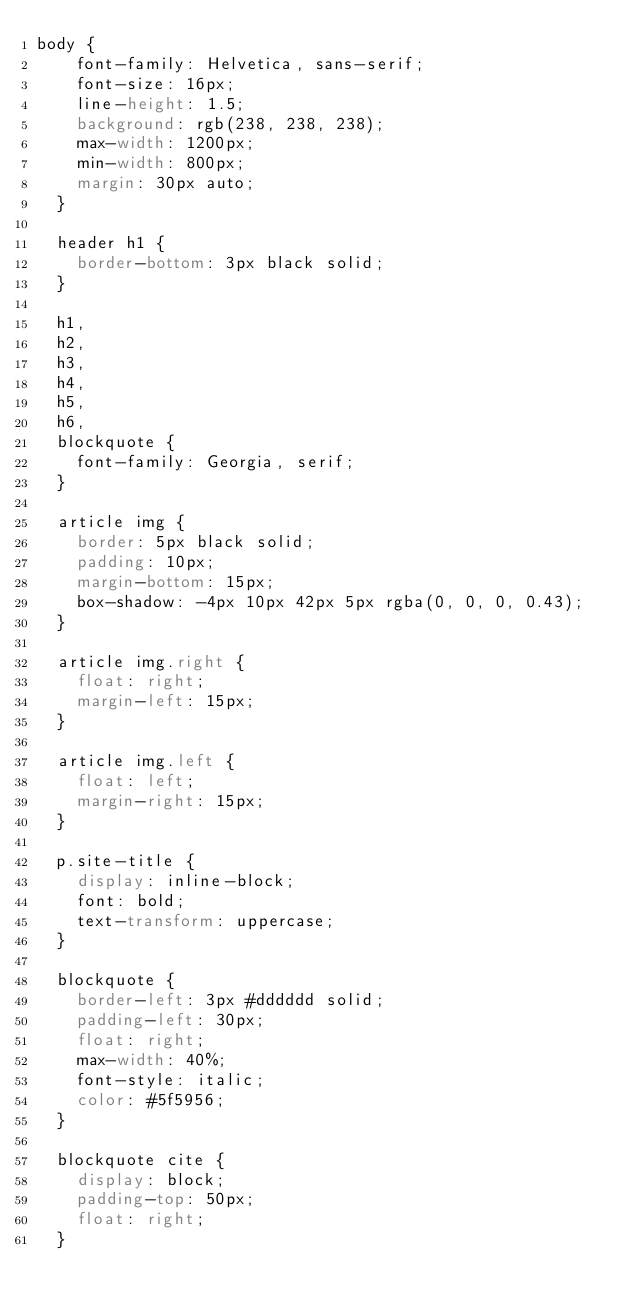Convert code to text. <code><loc_0><loc_0><loc_500><loc_500><_CSS_>body {
    font-family: Helvetica, sans-serif;
    font-size: 16px;
    line-height: 1.5;
    background: rgb(238, 238, 238);
    max-width: 1200px;
    min-width: 800px;
    margin: 30px auto;
  }
  
  header h1 {
    border-bottom: 3px black solid;
  }
  
  h1,
  h2,
  h3,
  h4,
  h5,
  h6,
  blockquote {
    font-family: Georgia, serif;
  }
  
  article img {
    border: 5px black solid;
    padding: 10px;
    margin-bottom: 15px;
    box-shadow: -4px 10px 42px 5px rgba(0, 0, 0, 0.43);
  }
  
  article img.right {
    float: right;
    margin-left: 15px;
  }
  
  article img.left {
    float: left;
    margin-right: 15px;
  }
 
  p.site-title {
    display: inline-block;
    font: bold;
    text-transform: uppercase;
  }
  
  blockquote {
    border-left: 3px #dddddd solid;
    padding-left: 30px;
    float: right;
    max-width: 40%;
    font-style: italic;
    color: #5f5956;
  }
  
  blockquote cite {
    display: block;
    padding-top: 50px;
    float: right;
  }</code> 